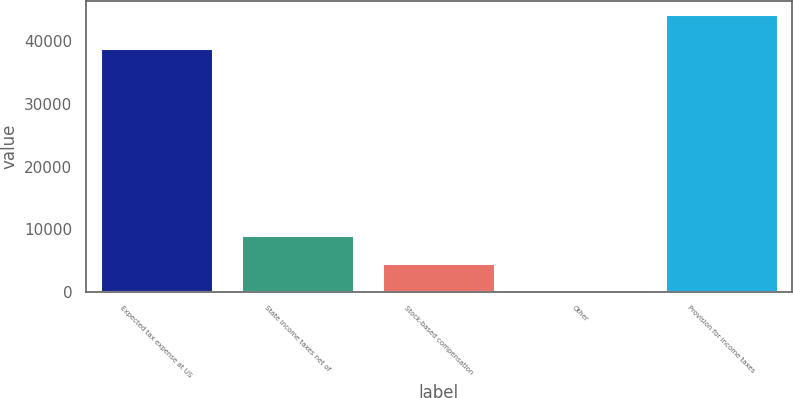<chart> <loc_0><loc_0><loc_500><loc_500><bar_chart><fcel>Expected tax expense at US<fcel>State income taxes net of<fcel>Stock-based compensation<fcel>Other<fcel>Provision for income taxes<nl><fcel>39025<fcel>9021.8<fcel>4609.9<fcel>198<fcel>44317<nl></chart> 